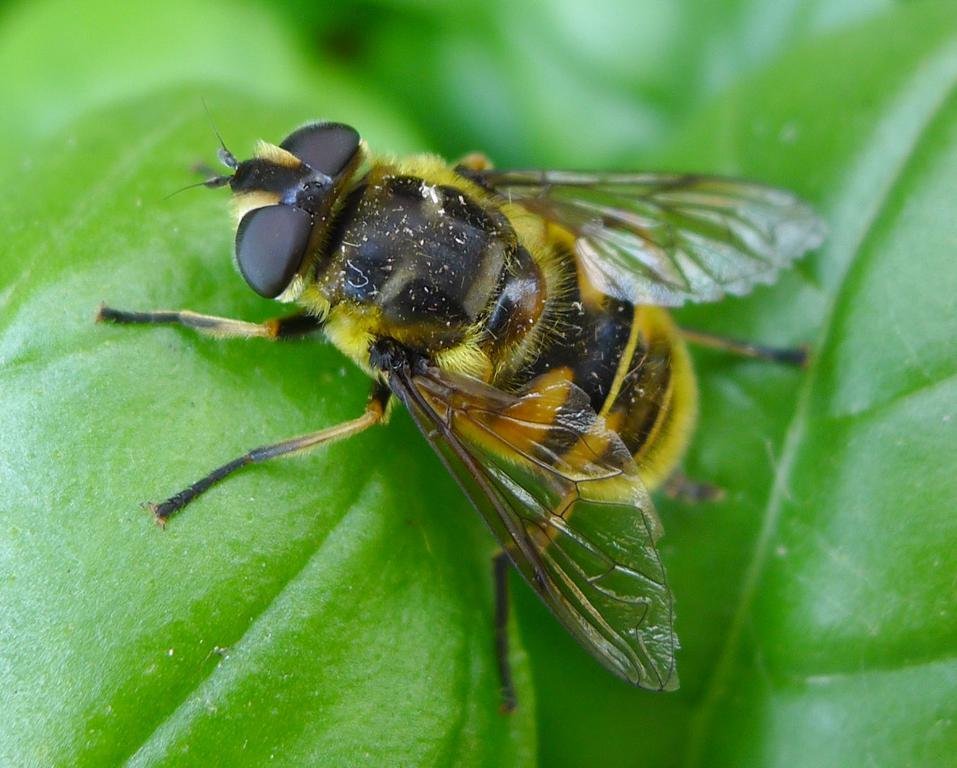What type of insect is present in the image? There is a honey bee in the image. Where is the honey bee located? The honey bee is on a leaf. Why is the honey bee crying in the image? There is no indication that the honey bee is crying in the image, as honey bees do not have the ability to cry. 